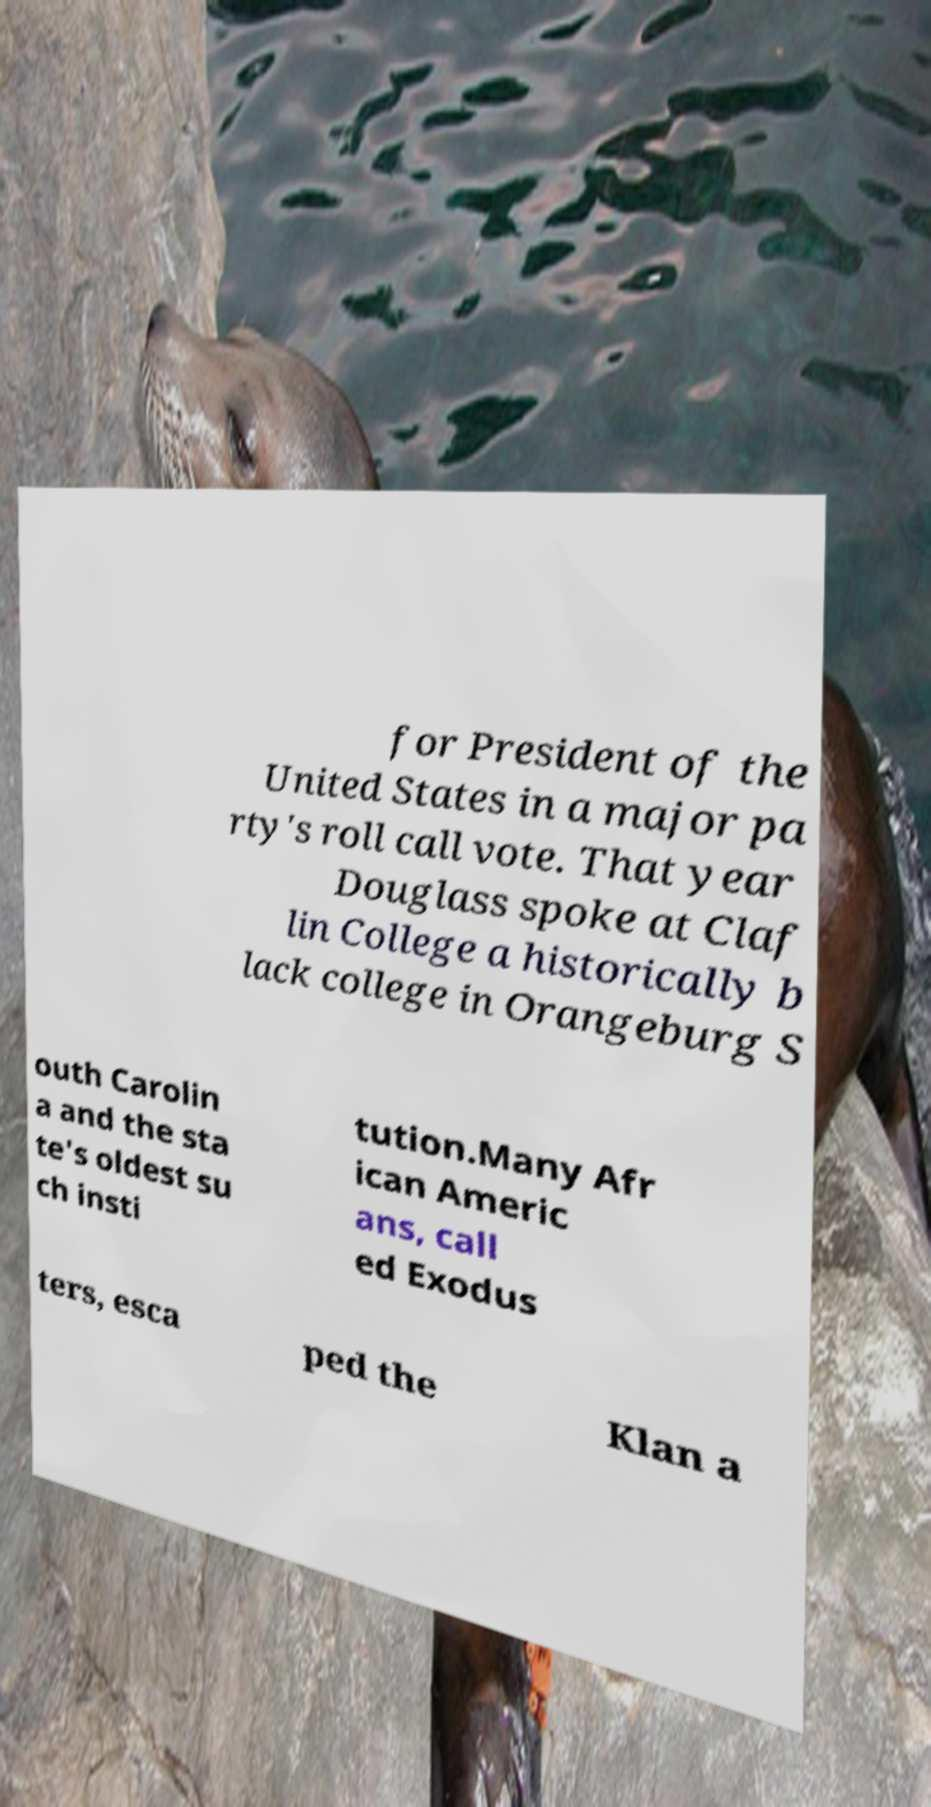For documentation purposes, I need the text within this image transcribed. Could you provide that? for President of the United States in a major pa rty's roll call vote. That year Douglass spoke at Claf lin College a historically b lack college in Orangeburg S outh Carolin a and the sta te's oldest su ch insti tution.Many Afr ican Americ ans, call ed Exodus ters, esca ped the Klan a 